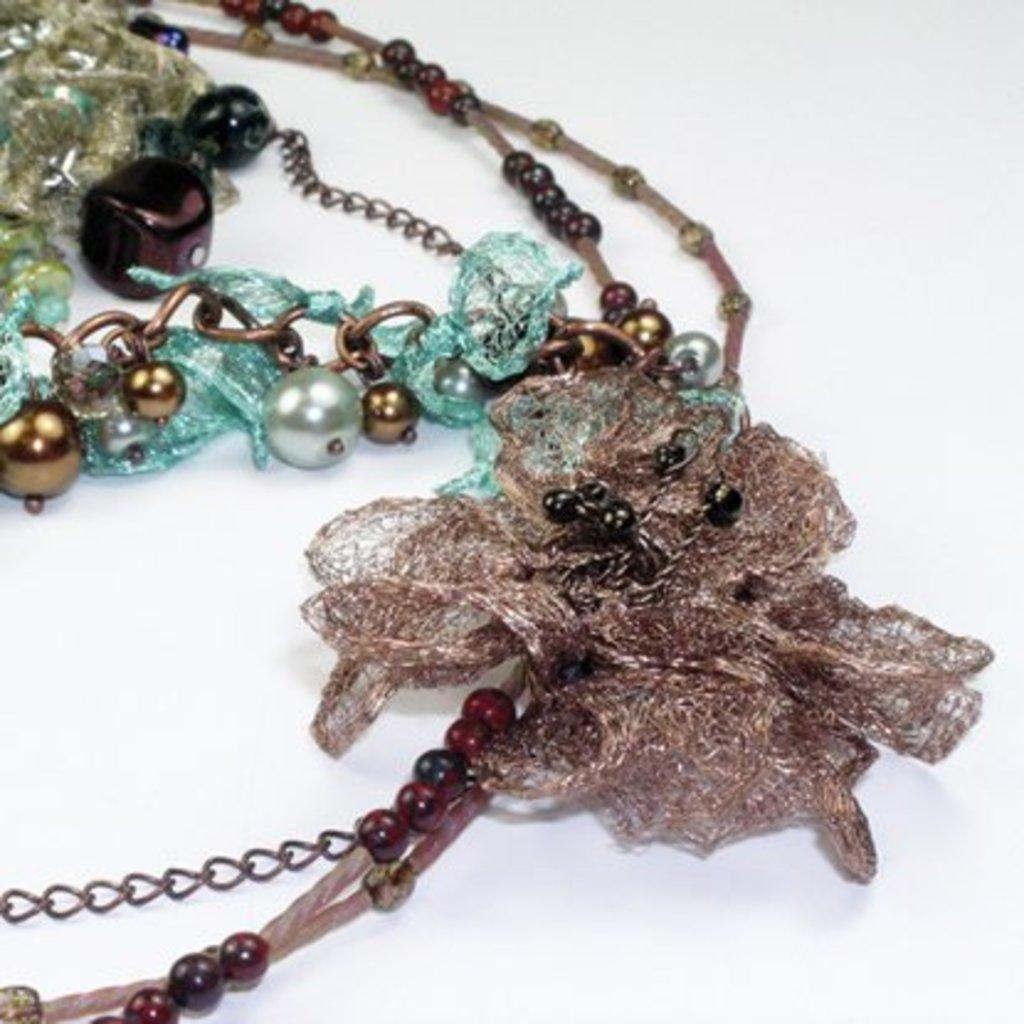What color is the background of the image? The background of the image is white. What can be seen on the surface in the middle of the image? There are chains on the surface in the middle of the image. What type of zebra can be seen holding an umbrella in the image? There is no zebra or umbrella present in the image. Can you solve the riddle hidden in the image? There is no riddle present in the image; it only features chains on a white background. 